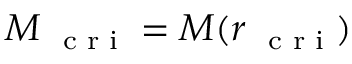Convert formula to latex. <formula><loc_0><loc_0><loc_500><loc_500>M _ { c r i } = M ( r _ { c r i } )</formula> 